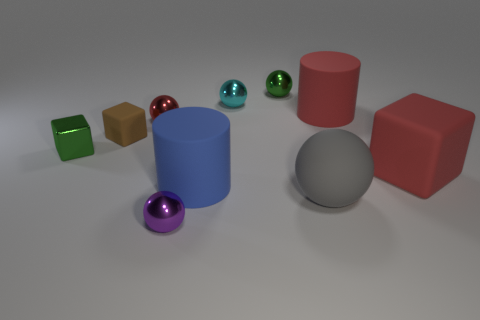Subtract all tiny purple spheres. How many spheres are left? 4 Subtract all gray balls. How many balls are left? 4 Subtract all yellow balls. Subtract all blue blocks. How many balls are left? 5 Subtract all blocks. How many objects are left? 7 Add 4 green cubes. How many green cubes are left? 5 Add 1 big red cubes. How many big red cubes exist? 2 Subtract 1 brown cubes. How many objects are left? 9 Subtract all small metallic cubes. Subtract all cylinders. How many objects are left? 7 